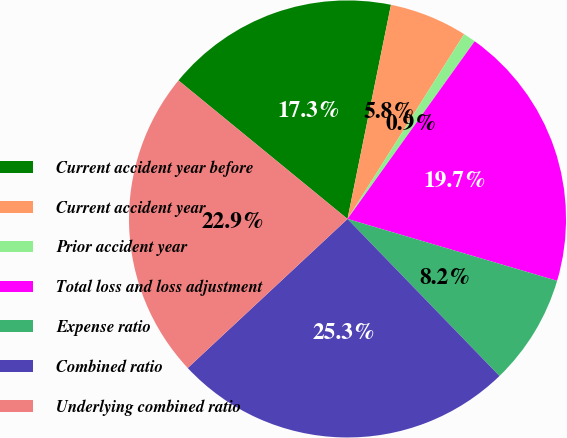Convert chart. <chart><loc_0><loc_0><loc_500><loc_500><pie_chart><fcel>Current accident year before<fcel>Current accident year<fcel>Prior accident year<fcel>Total loss and loss adjustment<fcel>Expense ratio<fcel>Combined ratio<fcel>Underlying combined ratio<nl><fcel>17.26%<fcel>5.77%<fcel>0.93%<fcel>19.68%<fcel>8.19%<fcel>25.29%<fcel>22.87%<nl></chart> 